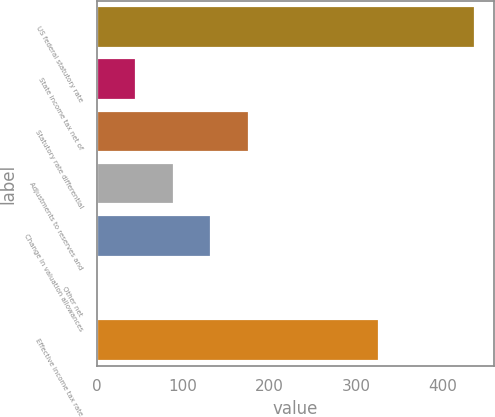Convert chart to OTSL. <chart><loc_0><loc_0><loc_500><loc_500><bar_chart><fcel>US federal statutory rate<fcel>State income tax net of<fcel>Statutory rate differential<fcel>Adjustments to reserves and<fcel>Change in valuation allowances<fcel>Other net<fcel>Effective income tax rate<nl><fcel>438<fcel>45.6<fcel>176.4<fcel>89.2<fcel>132.8<fcel>2<fcel>327<nl></chart> 